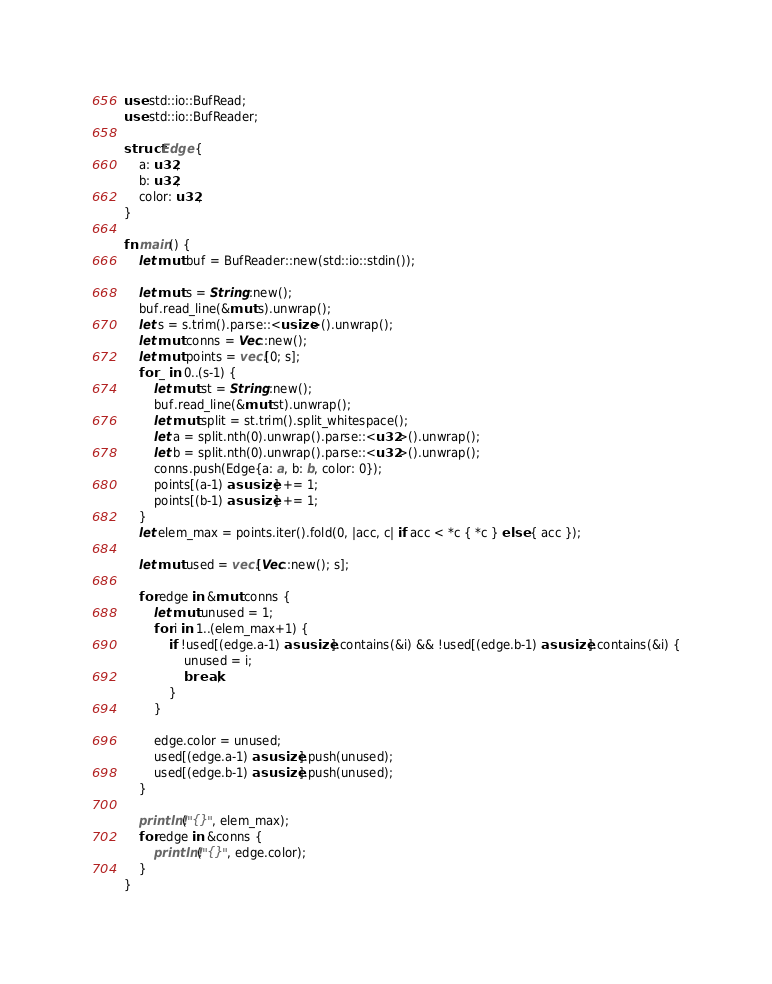<code> <loc_0><loc_0><loc_500><loc_500><_Rust_>use std::io::BufRead;
use std::io::BufReader;

struct Edge {
    a: u32,
    b: u32,
    color: u32,
}

fn main() {
    let mut buf = BufReader::new(std::io::stdin());

    let mut s = String::new();
    buf.read_line(&mut s).unwrap();
    let s = s.trim().parse::<usize>().unwrap();
    let mut conns = Vec::new();
    let mut points = vec![0; s];
    for _ in 0..(s-1) {
        let mut st = String::new();
        buf.read_line(&mut st).unwrap();
        let mut split = st.trim().split_whitespace();
        let a = split.nth(0).unwrap().parse::<u32>().unwrap();
        let b = split.nth(0).unwrap().parse::<u32>().unwrap();
        conns.push(Edge{a: a, b: b, color: 0});
        points[(a-1) as usize] += 1;
        points[(b-1) as usize] += 1;
    }
    let elem_max = points.iter().fold(0, |acc, c| if acc < *c { *c } else { acc });

    let mut used = vec![Vec::new(); s];

    for edge in &mut conns {
        let mut unused = 1;
        for i in 1..(elem_max+1) {
            if !used[(edge.a-1) as usize].contains(&i) && !used[(edge.b-1) as usize].contains(&i) {
                unused = i;
                break;
            }
        }

        edge.color = unused;
        used[(edge.a-1) as usize].push(unused);
        used[(edge.b-1) as usize].push(unused);
    }

    println!("{}", elem_max);
    for edge in &conns {
        println!("{}", edge.color);
    }
}</code> 